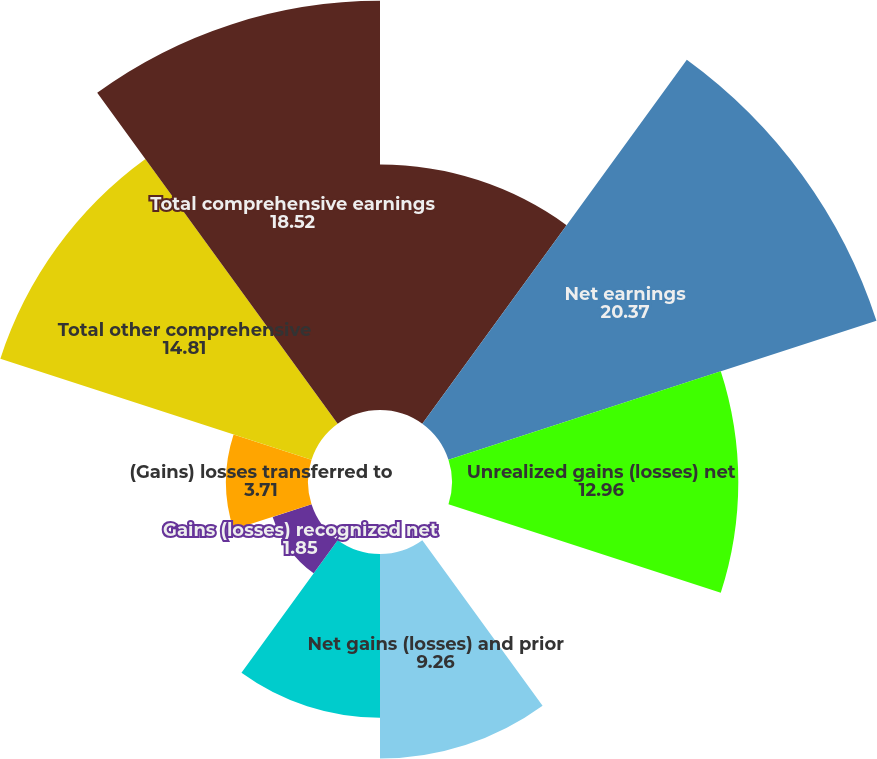Convert chart. <chart><loc_0><loc_0><loc_500><loc_500><pie_chart><fcel>for the years ended December<fcel>Net earnings<fcel>Unrealized gains (losses) net<fcel>(Gains)/losses transferred to<fcel>Net gains (losses) and prior<fcel>Amortization of net losses<fcel>Gains (losses) recognized net<fcel>(Gains) losses transferred to<fcel>Total other comprehensive<fcel>Total comprehensive earnings<nl><fcel>11.11%<fcel>20.37%<fcel>12.96%<fcel>0.0%<fcel>9.26%<fcel>7.41%<fcel>1.85%<fcel>3.71%<fcel>14.81%<fcel>18.52%<nl></chart> 